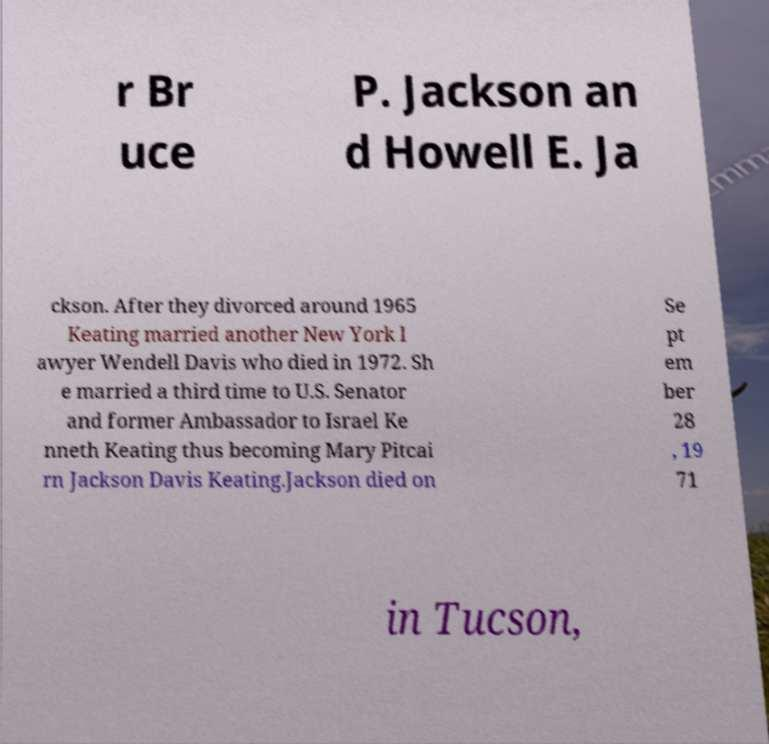Can you accurately transcribe the text from the provided image for me? r Br uce P. Jackson an d Howell E. Ja ckson. After they divorced around 1965 Keating married another New York l awyer Wendell Davis who died in 1972. Sh e married a third time to U.S. Senator and former Ambassador to Israel Ke nneth Keating thus becoming Mary Pitcai rn Jackson Davis Keating.Jackson died on Se pt em ber 28 , 19 71 in Tucson, 